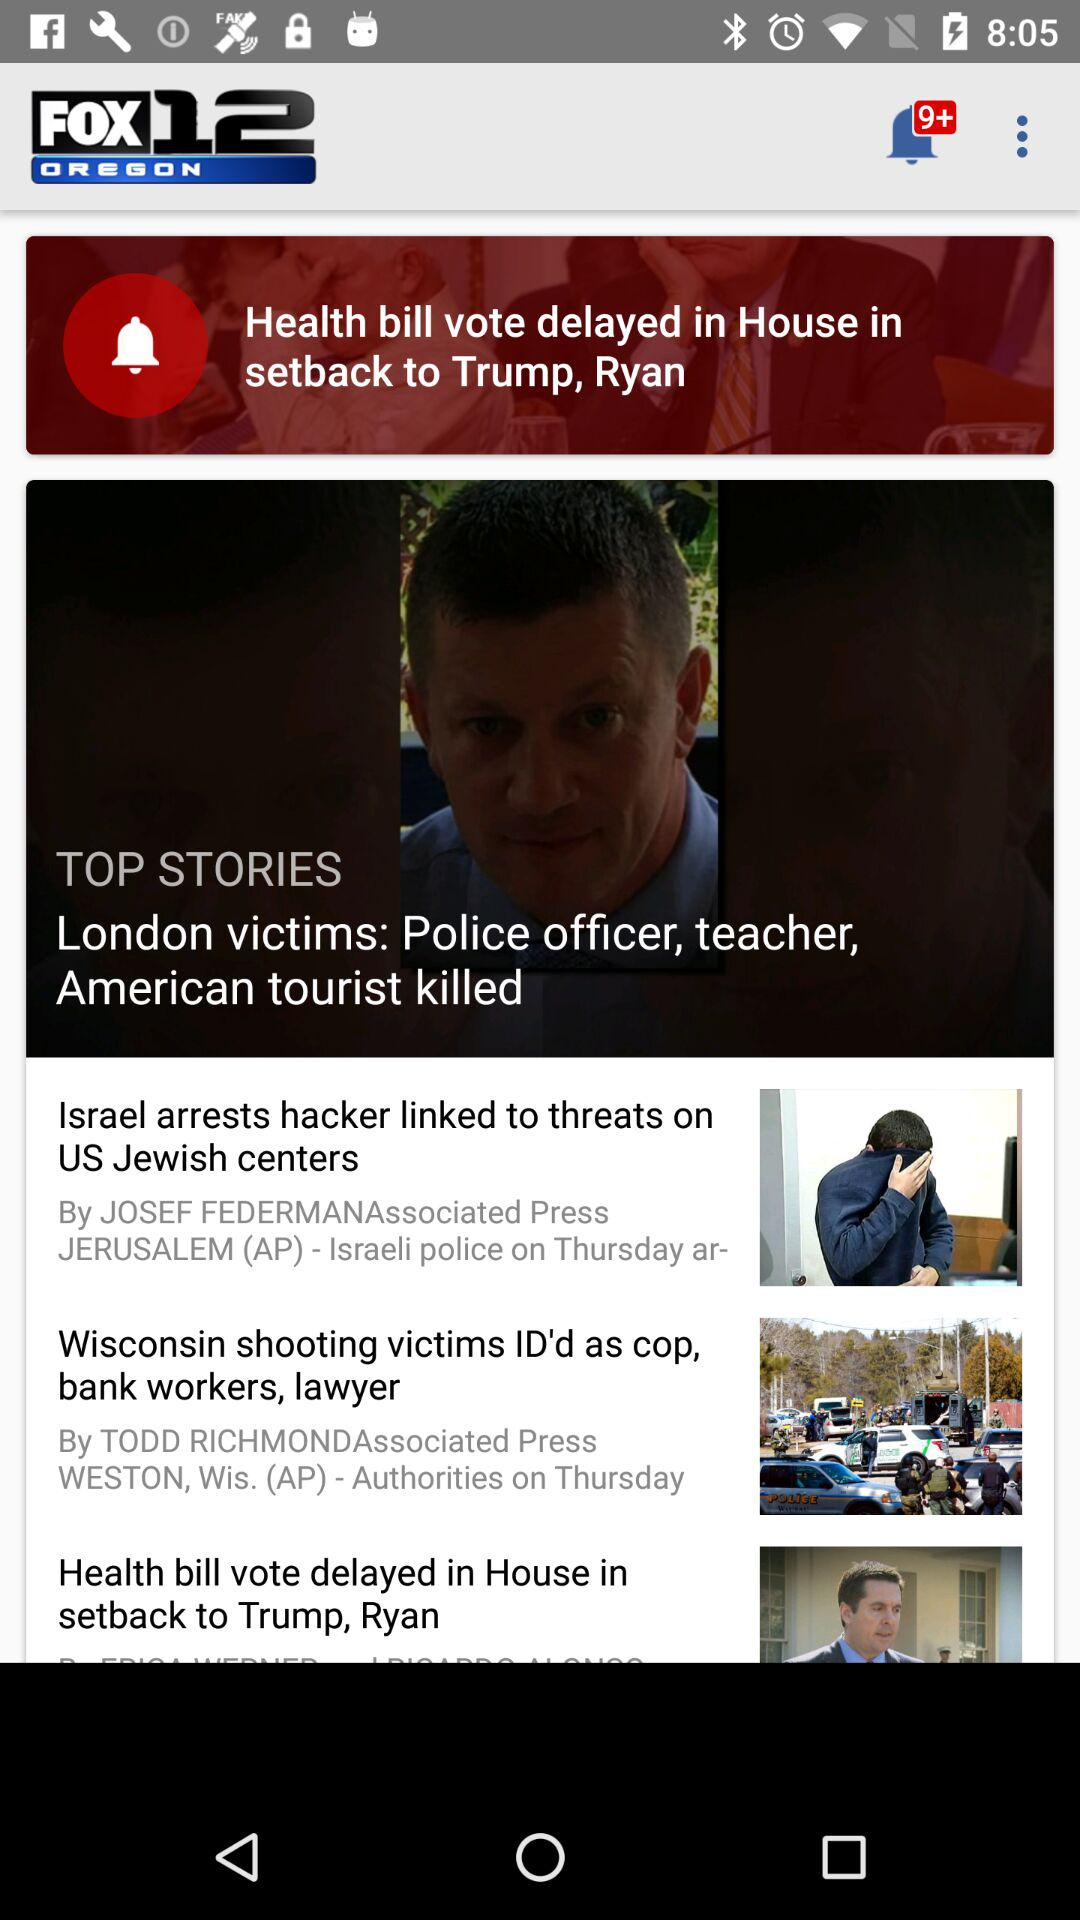How many new notifications? There are more than nine new notifications. 